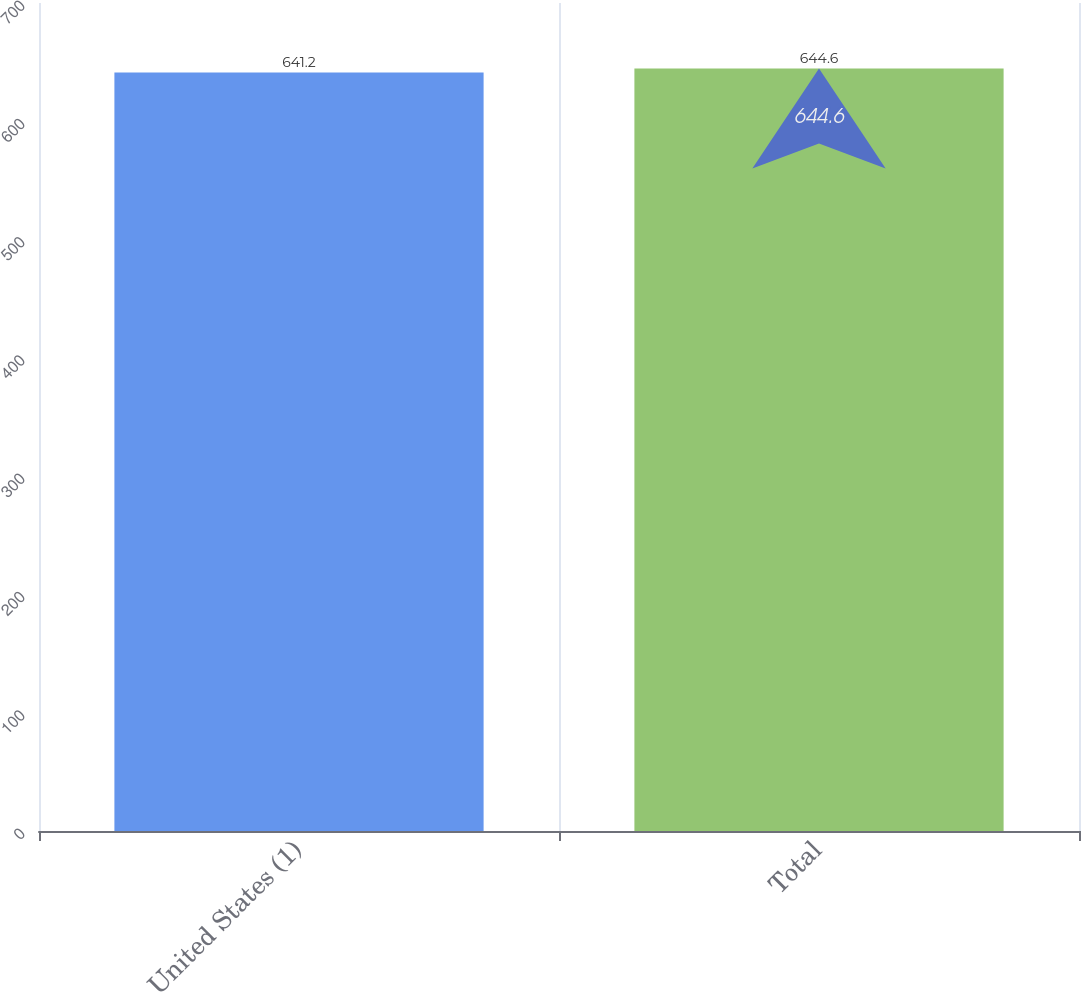Convert chart. <chart><loc_0><loc_0><loc_500><loc_500><bar_chart><fcel>United States (1)<fcel>Total<nl><fcel>641.2<fcel>644.6<nl></chart> 